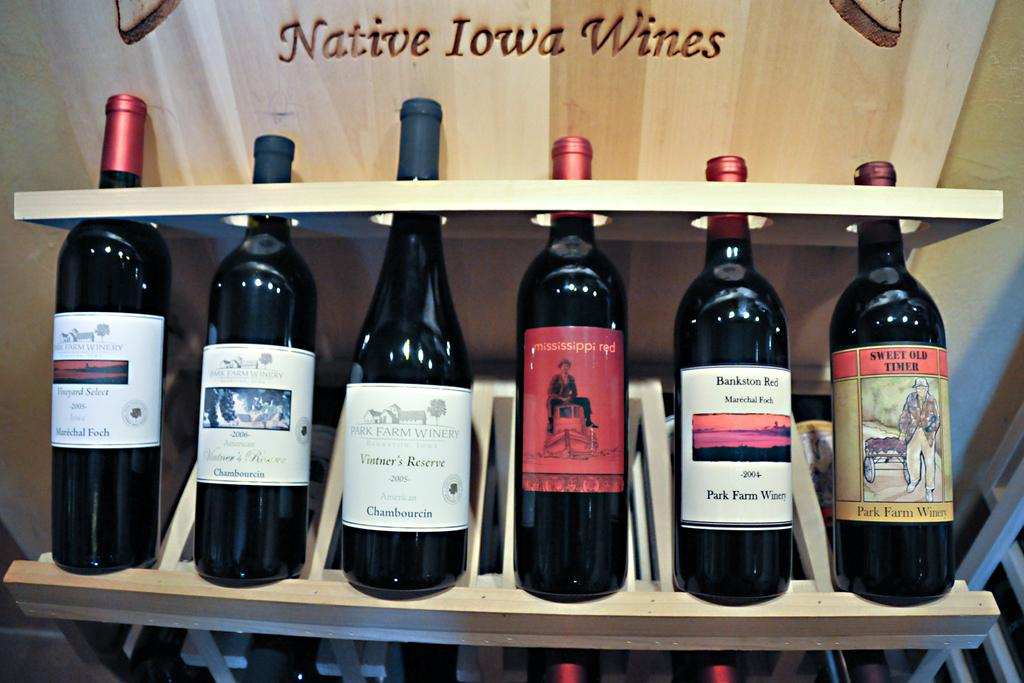<image>
Present a compact description of the photo's key features. A wooden display shows several Native Iowa Wines. 